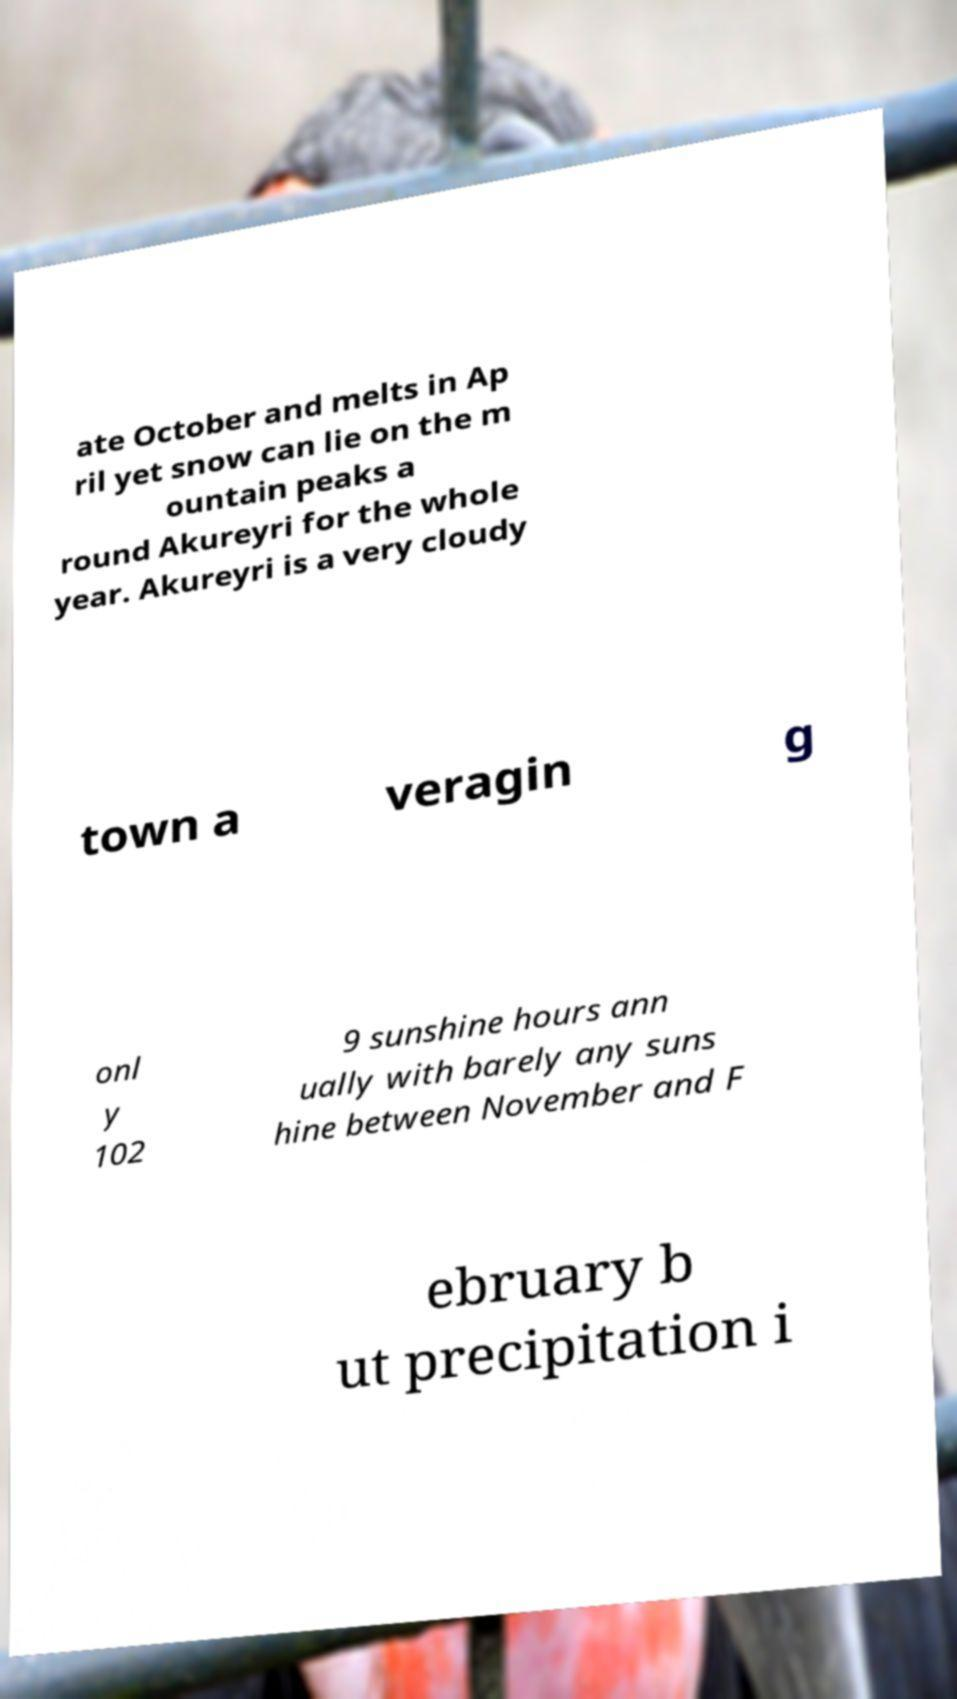Could you assist in decoding the text presented in this image and type it out clearly? ate October and melts in Ap ril yet snow can lie on the m ountain peaks a round Akureyri for the whole year. Akureyri is a very cloudy town a veragin g onl y 102 9 sunshine hours ann ually with barely any suns hine between November and F ebruary b ut precipitation i 